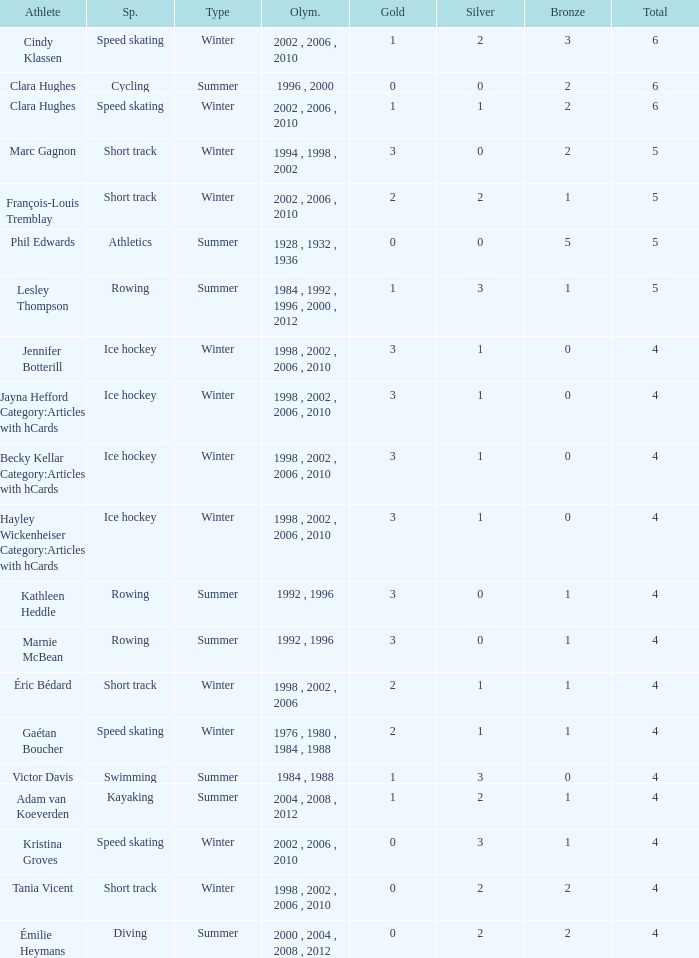What is the lowest number of bronze a short track athlete with 0 gold medals has? 2.0. 